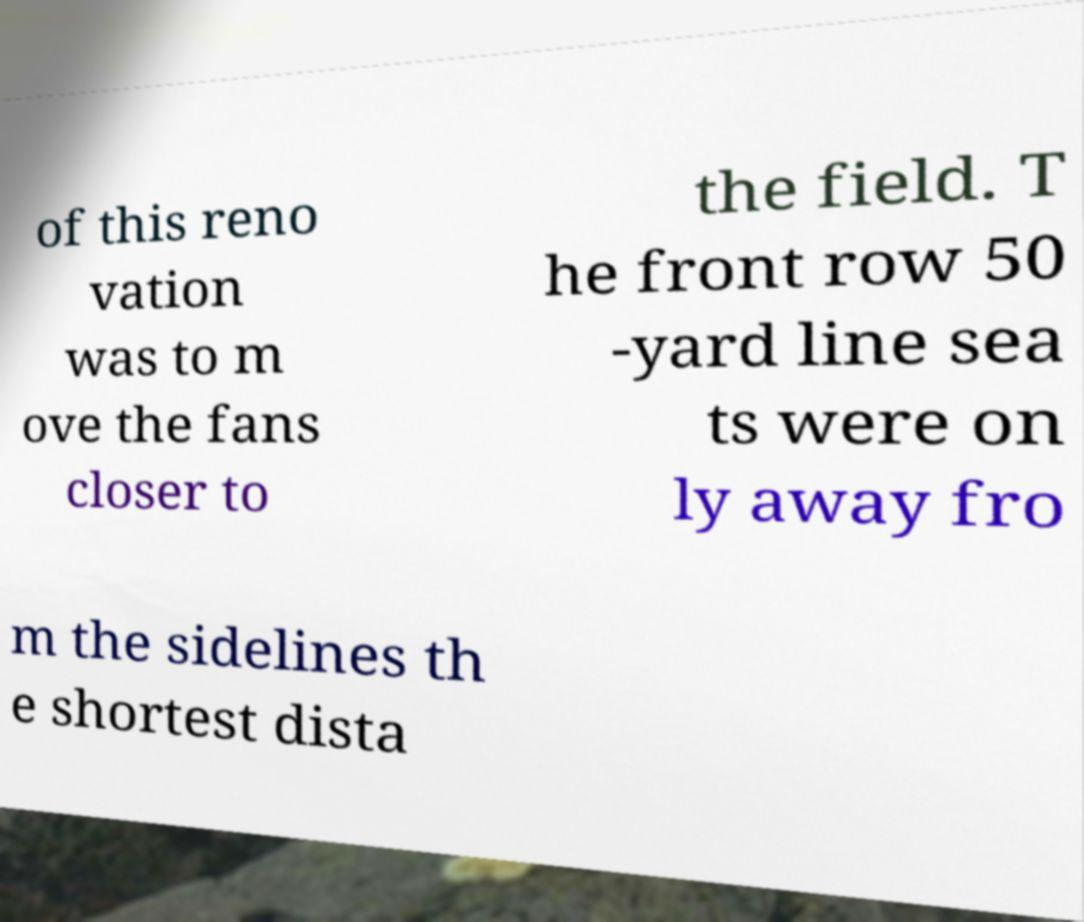Can you accurately transcribe the text from the provided image for me? of this reno vation was to m ove the fans closer to the field. T he front row 50 -yard line sea ts were on ly away fro m the sidelines th e shortest dista 